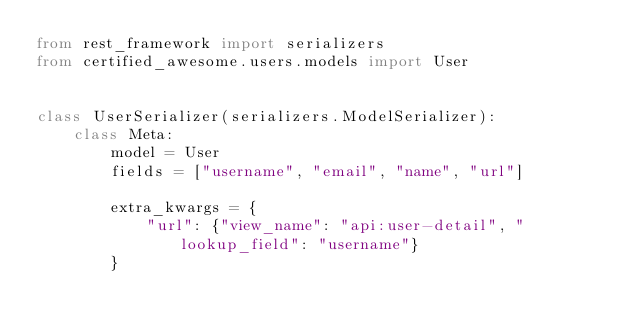Convert code to text. <code><loc_0><loc_0><loc_500><loc_500><_Python_>from rest_framework import serializers
from certified_awesome.users.models import User


class UserSerializer(serializers.ModelSerializer):
    class Meta:
        model = User
        fields = ["username", "email", "name", "url"]

        extra_kwargs = {
            "url": {"view_name": "api:user-detail", "lookup_field": "username"}
        }
</code> 